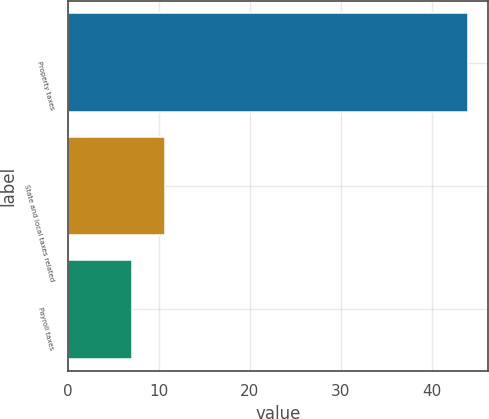<chart> <loc_0><loc_0><loc_500><loc_500><bar_chart><fcel>Property taxes<fcel>State and local taxes related<fcel>Payroll taxes<nl><fcel>44<fcel>10.7<fcel>7<nl></chart> 